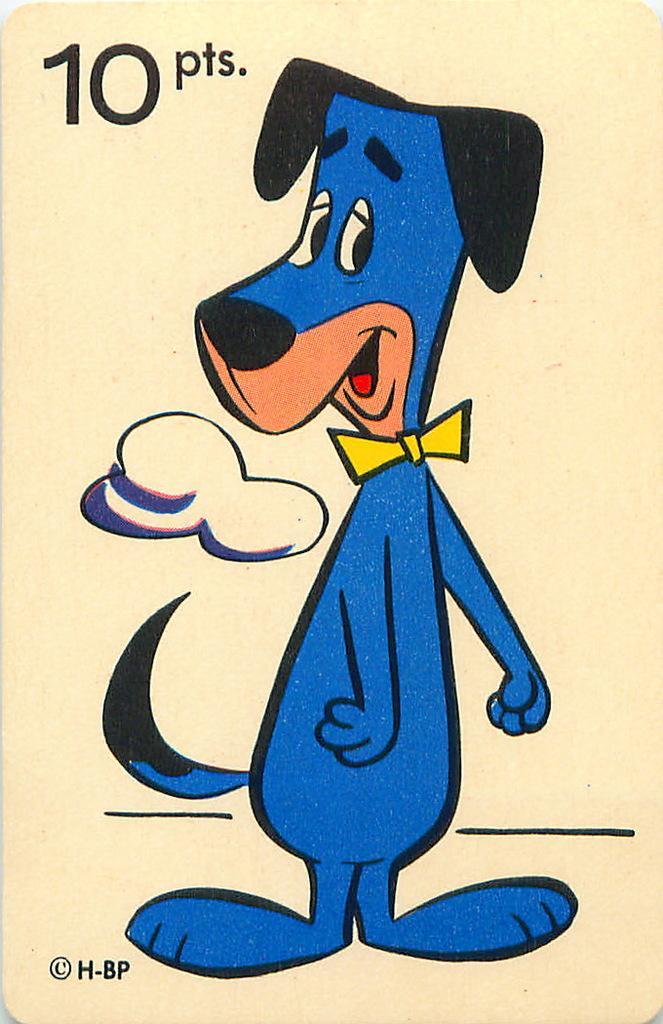What type of image is present in the picture? There is an anime image in the picture. Can you describe the subject of the anime image? The anime image depicts a blue dog. How would you classify the image in terms of its style or genre? The image appears to be a form of art, specifically anime. Where are the dolls resting in the image? There are no dolls present in the image. What is the drain used for in the image? There is no drain present in the image. 